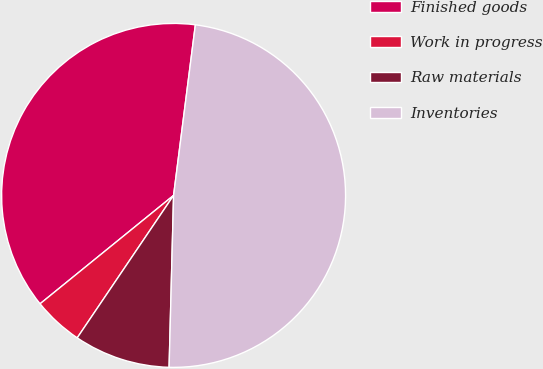Convert chart. <chart><loc_0><loc_0><loc_500><loc_500><pie_chart><fcel>Finished goods<fcel>Work in progress<fcel>Raw materials<fcel>Inventories<nl><fcel>37.87%<fcel>4.68%<fcel>9.05%<fcel>48.39%<nl></chart> 